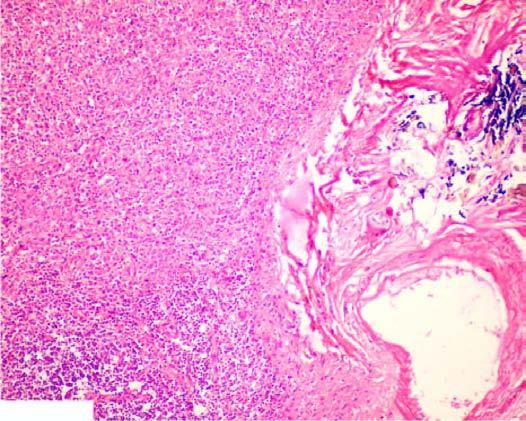s the necrosed area on right side of the field increased fibrosis in the red pulp, capsule and the trabeculae?
Answer the question using a single word or phrase. No 